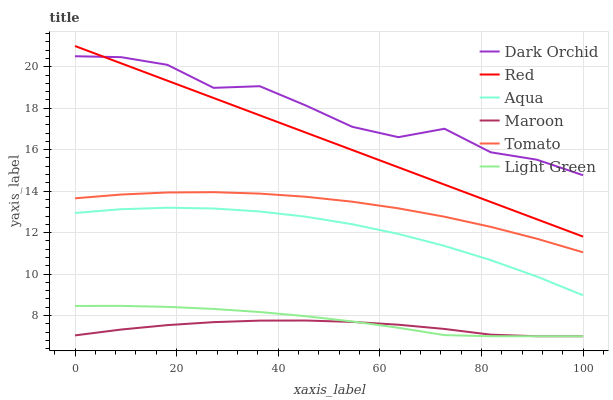Does Maroon have the minimum area under the curve?
Answer yes or no. Yes. Does Dark Orchid have the maximum area under the curve?
Answer yes or no. Yes. Does Aqua have the minimum area under the curve?
Answer yes or no. No. Does Aqua have the maximum area under the curve?
Answer yes or no. No. Is Red the smoothest?
Answer yes or no. Yes. Is Dark Orchid the roughest?
Answer yes or no. Yes. Is Aqua the smoothest?
Answer yes or no. No. Is Aqua the roughest?
Answer yes or no. No. Does Maroon have the lowest value?
Answer yes or no. Yes. Does Aqua have the lowest value?
Answer yes or no. No. Does Red have the highest value?
Answer yes or no. Yes. Does Aqua have the highest value?
Answer yes or no. No. Is Light Green less than Dark Orchid?
Answer yes or no. Yes. Is Dark Orchid greater than Aqua?
Answer yes or no. Yes. Does Dark Orchid intersect Red?
Answer yes or no. Yes. Is Dark Orchid less than Red?
Answer yes or no. No. Is Dark Orchid greater than Red?
Answer yes or no. No. Does Light Green intersect Dark Orchid?
Answer yes or no. No. 